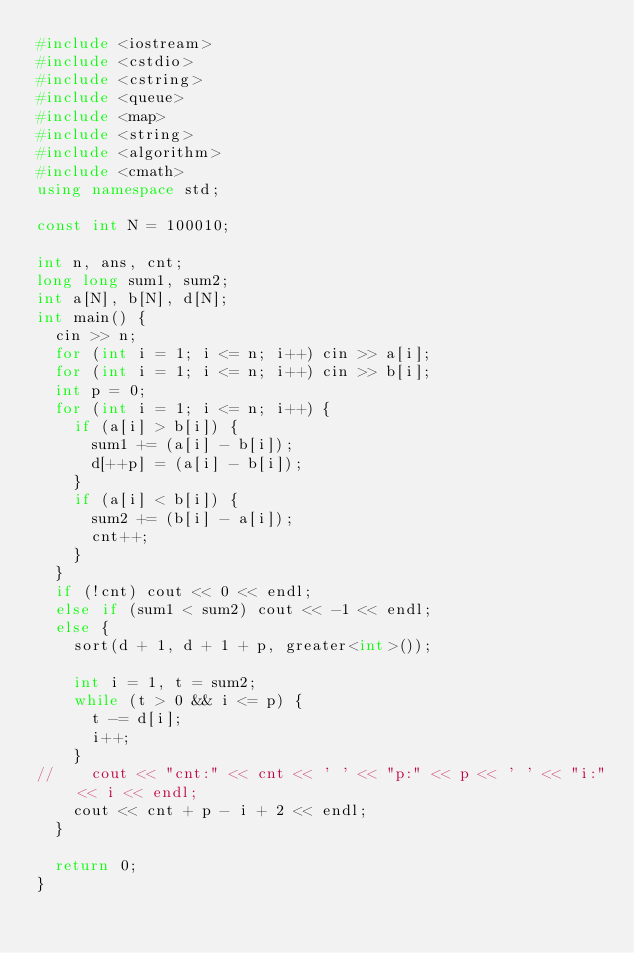<code> <loc_0><loc_0><loc_500><loc_500><_C++_>#include <iostream>
#include <cstdio>
#include <cstring>
#include <queue>
#include <map>
#include <string>
#include <algorithm>
#include <cmath>
using namespace std;

const int N = 100010;

int n, ans, cnt;
long long sum1, sum2;
int a[N], b[N], d[N];
int main() {
	cin >> n;
	for (int i = 1; i <= n; i++) cin >> a[i];
	for (int i = 1; i <= n; i++) cin >> b[i];
	int p = 0;
	for (int i = 1; i <= n; i++) {
		if (a[i] > b[i]) {
			sum1 += (a[i] - b[i]);
			d[++p] = (a[i] - b[i]);
		}
		if (a[i] < b[i]) {
			sum2 += (b[i] - a[i]);
			cnt++;
		}
	}
	if (!cnt) cout << 0 << endl;
	else if (sum1 < sum2) cout << -1 << endl;
	else {
		sort(d + 1, d + 1 + p, greater<int>());
		
		int i = 1, t = sum2;
		while (t > 0 && i <= p) {
			t -= d[i];
			i++;
		}
//		cout << "cnt:" << cnt << ' ' << "p:" << p << ' ' << "i:" << i << endl;
		cout << cnt + p - i + 2 << endl;
	}
	
	return 0;
}</code> 